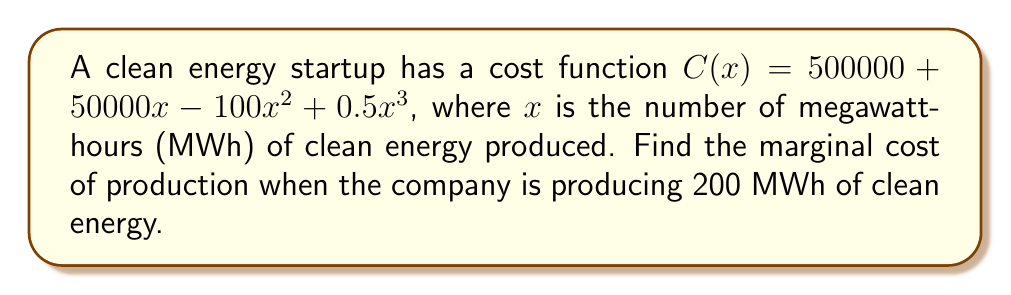Could you help me with this problem? To find the marginal cost, we need to calculate the derivative of the cost function $C(x)$ and then evaluate it at $x = 200$.

Step 1: Calculate the derivative of $C(x)$
$$\begin{align}
C(x) &= 500000 + 50000x - 100x^2 + 0.5x^3 \\
C'(x) &= 50000 - 200x + 1.5x^2
\end{align}$$

Step 2: Evaluate $C'(x)$ at $x = 200$
$$\begin{align}
C'(200) &= 50000 - 200(200) + 1.5(200)^2 \\
&= 50000 - 40000 + 1.5(40000) \\
&= 50000 - 40000 + 60000 \\
&= 70000
\end{align}$$

Step 3: Interpret the result
The marginal cost is $70,000 per additional MWh of clean energy when producing 200 MWh.
Answer: $70,000 per MWh 